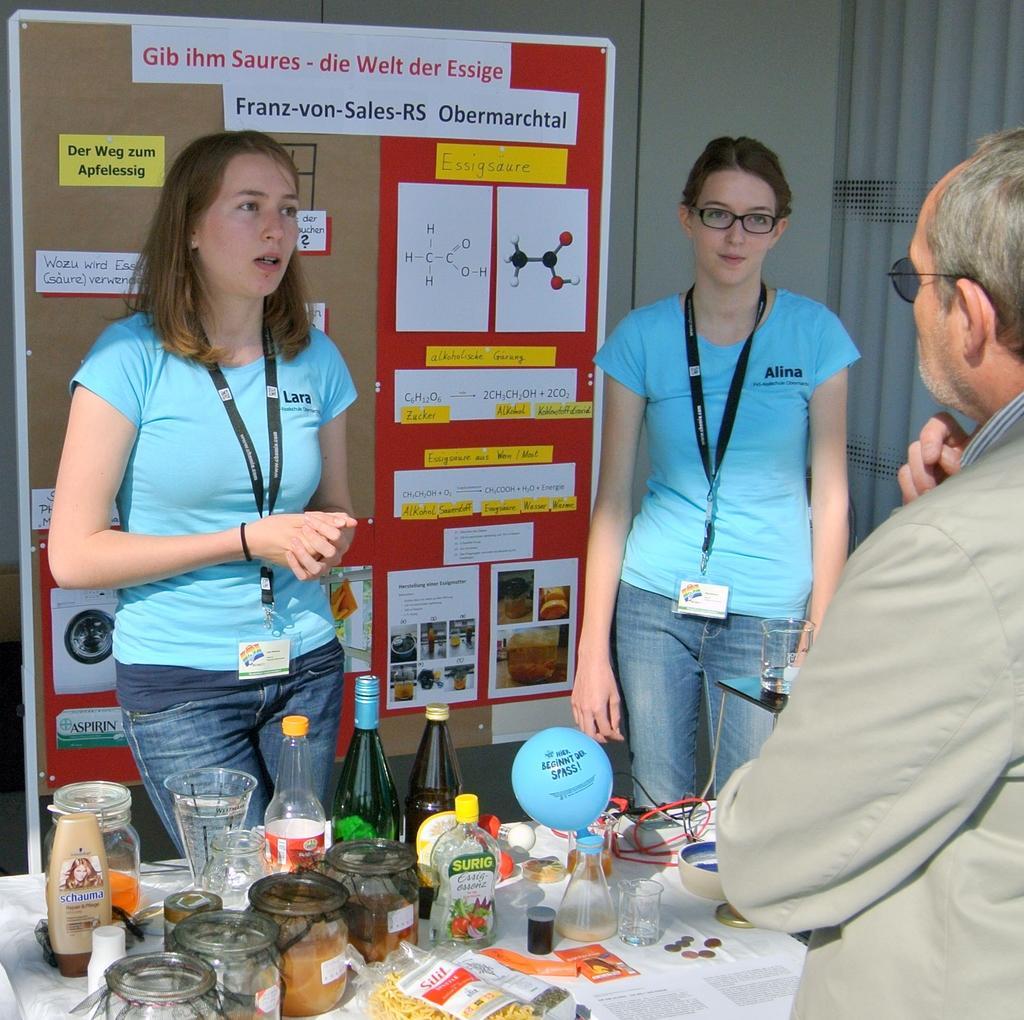How would you summarize this image in a sentence or two? On the right side we can see a man is standing and there are bottles, glass, items in the jars, cables, conical flask and objects are on the table and we can see two women are standing at the table. In the background we can see posters and papers on the board and we can see the wall. 